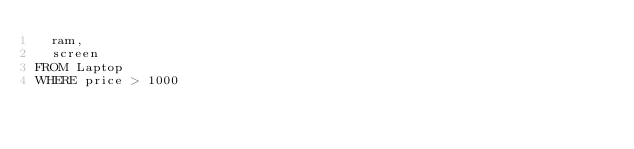<code> <loc_0><loc_0><loc_500><loc_500><_SQL_>  ram,
  screen
FROM Laptop
WHERE price > 1000</code> 